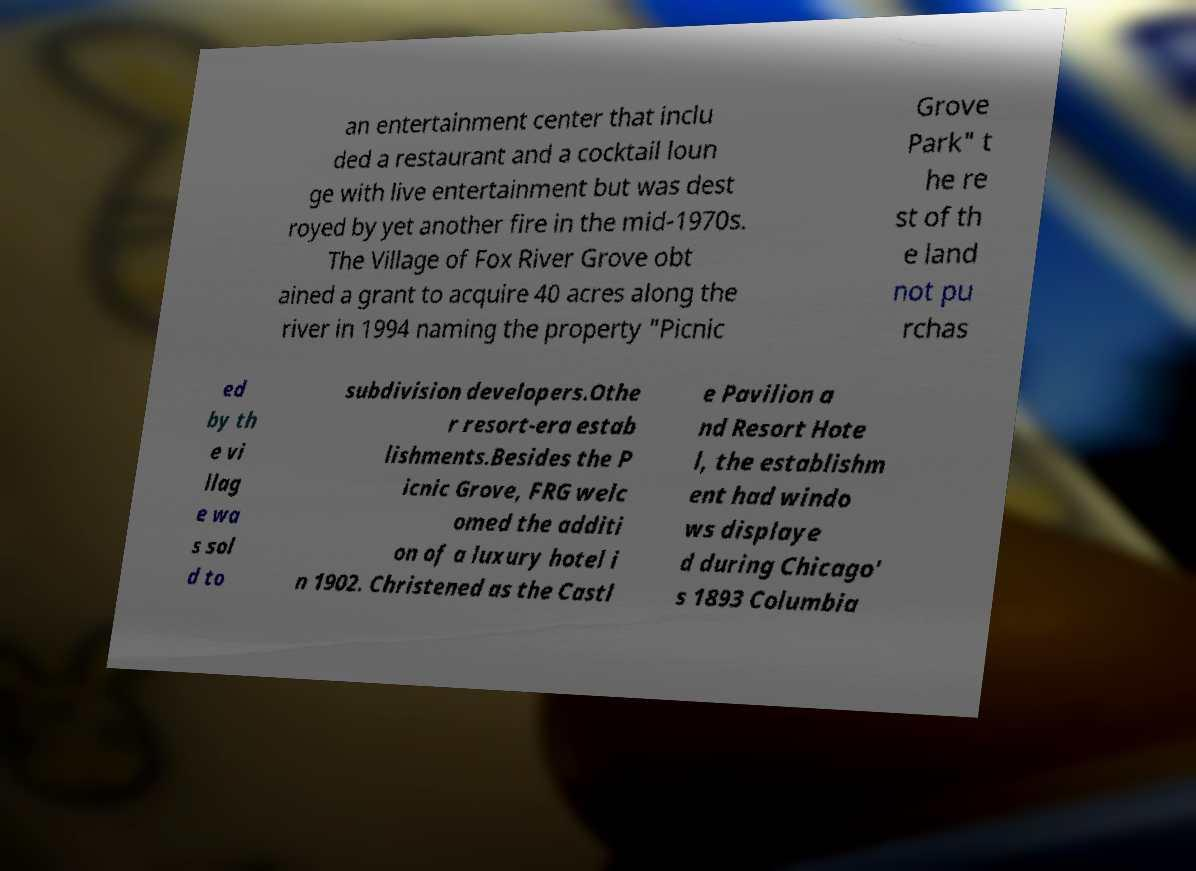For documentation purposes, I need the text within this image transcribed. Could you provide that? an entertainment center that inclu ded a restaurant and a cocktail loun ge with live entertainment but was dest royed by yet another fire in the mid-1970s. The Village of Fox River Grove obt ained a grant to acquire 40 acres along the river in 1994 naming the property "Picnic Grove Park" t he re st of th e land not pu rchas ed by th e vi llag e wa s sol d to subdivision developers.Othe r resort-era estab lishments.Besides the P icnic Grove, FRG welc omed the additi on of a luxury hotel i n 1902. Christened as the Castl e Pavilion a nd Resort Hote l, the establishm ent had windo ws displaye d during Chicago' s 1893 Columbia 